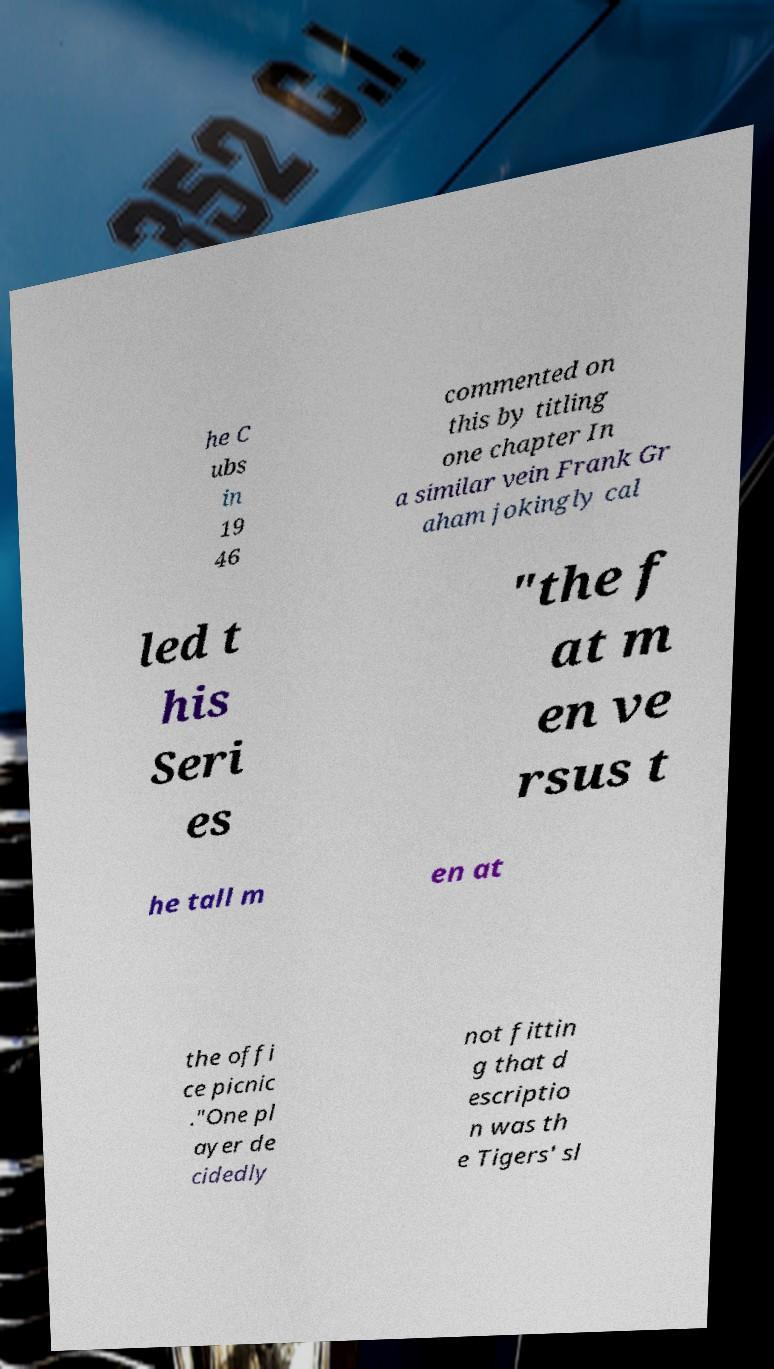What messages or text are displayed in this image? I need them in a readable, typed format. he C ubs in 19 46 commented on this by titling one chapter In a similar vein Frank Gr aham jokingly cal led t his Seri es "the f at m en ve rsus t he tall m en at the offi ce picnic ."One pl ayer de cidedly not fittin g that d escriptio n was th e Tigers' sl 